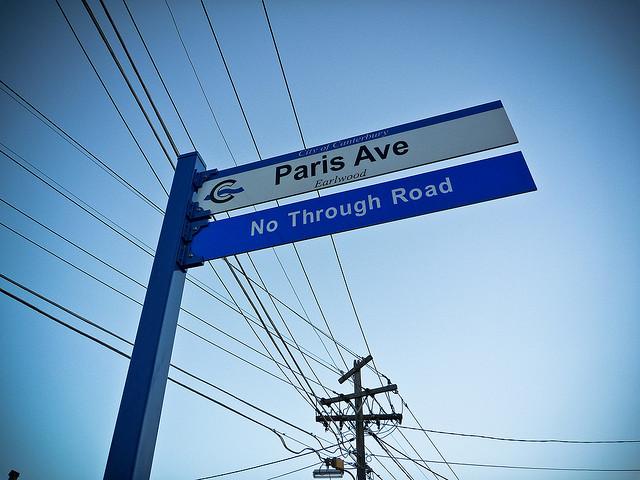Is this a street sign?
Be succinct. Yes. What Avenue is shown?
Give a very brief answer. Paris. What color is the sky in this scene?
Quick response, please. Blue. What lines are shown?
Answer briefly. Power. 